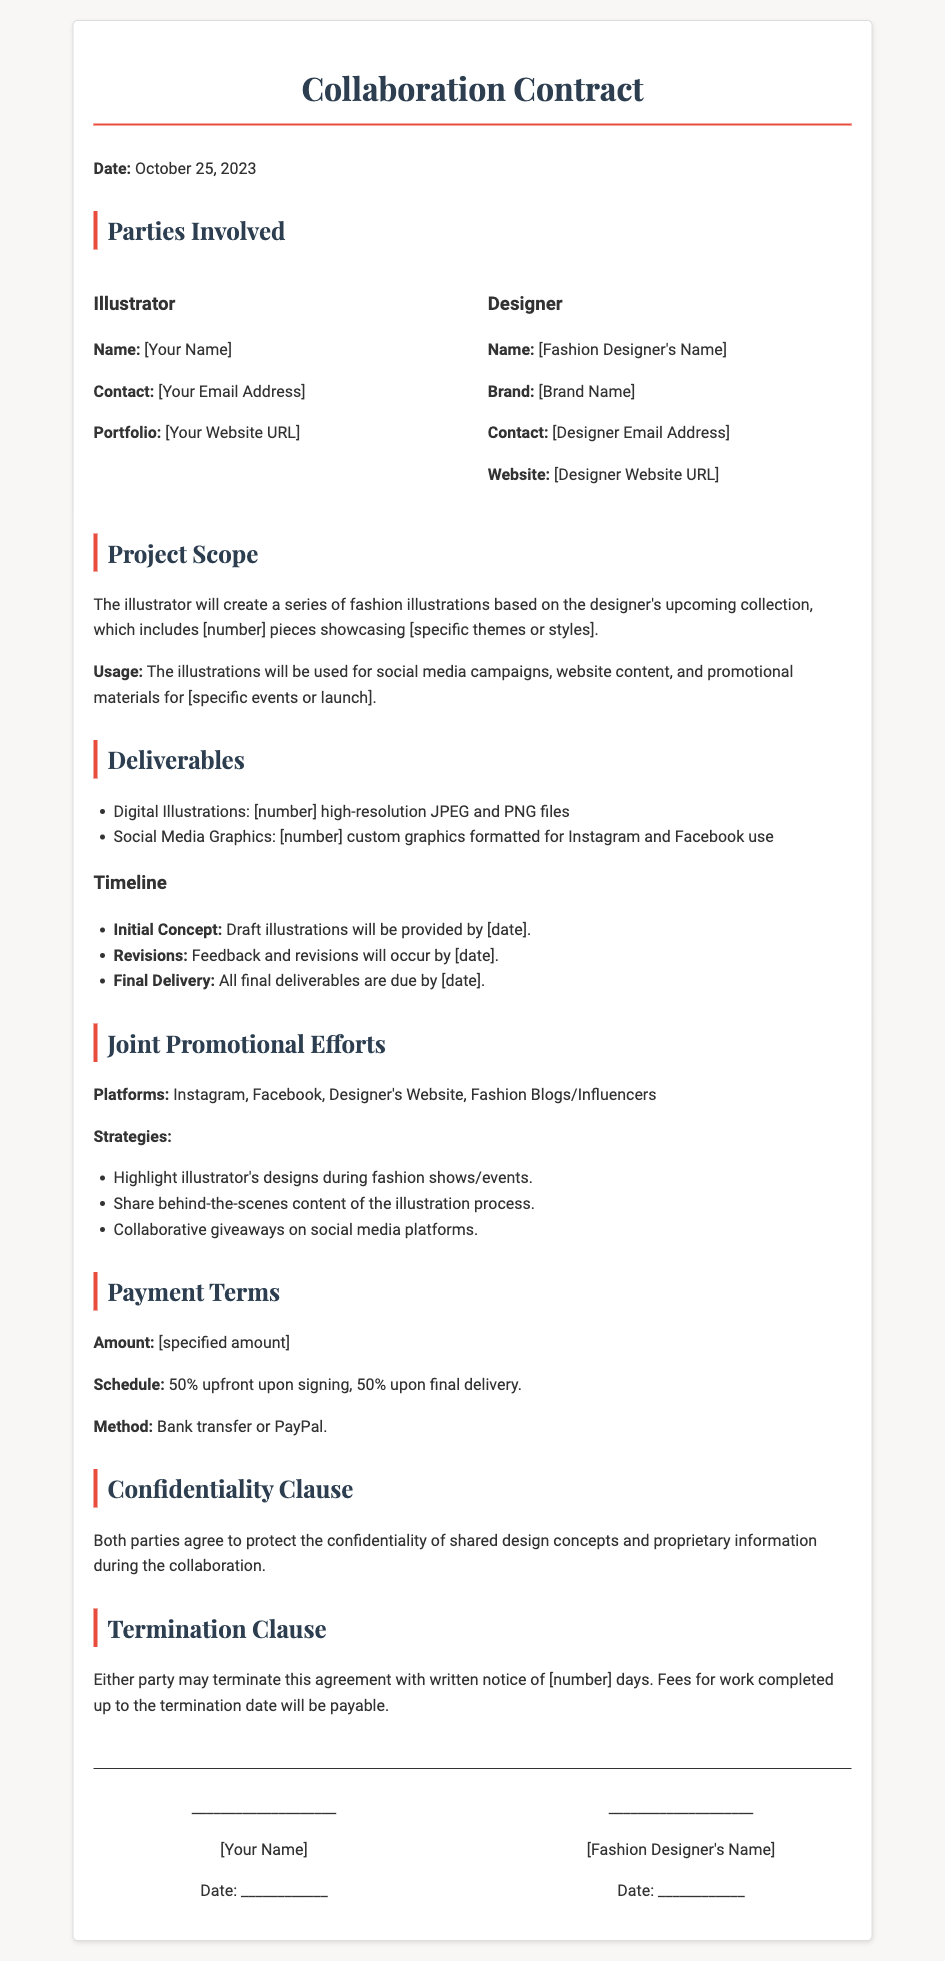what is the date of the contract? The date of the contract is mentioned at the beginning of the document.
Answer: October 25, 2023 who is the illustrator? The document specifies the name of the illustrator in the parties involved section.
Answer: [Your Name] what is the designer's brand name? The brand name of the designer is included under the designer's information.
Answer: [Brand Name] what is the total number of digital illustrations to be delivered? The document references the number of high-resolution files to be delivered under the deliverables section.
Answer: [number] when will the initial concept be provided? The timeline section indicates when the draft illustrations will be available.
Answer: [date] how much is the upfront payment percentage? The payment terms specify the percentage required upfront upon signing the contract.
Answer: 50% which platforms are mentioned for joint promotional efforts? The document lists the platforms where promotional activities will take place.
Answer: Instagram, Facebook, Designer's Website, Fashion Blogs/Influencers what happens if either party wants to terminate the agreement? The termination clause explains the action required for either party to end the collaboration.
Answer: Written notice of [number] days what is the payment method accepted? The payment terms indicate the methods that can be used for transactions.
Answer: Bank transfer or PayPal 